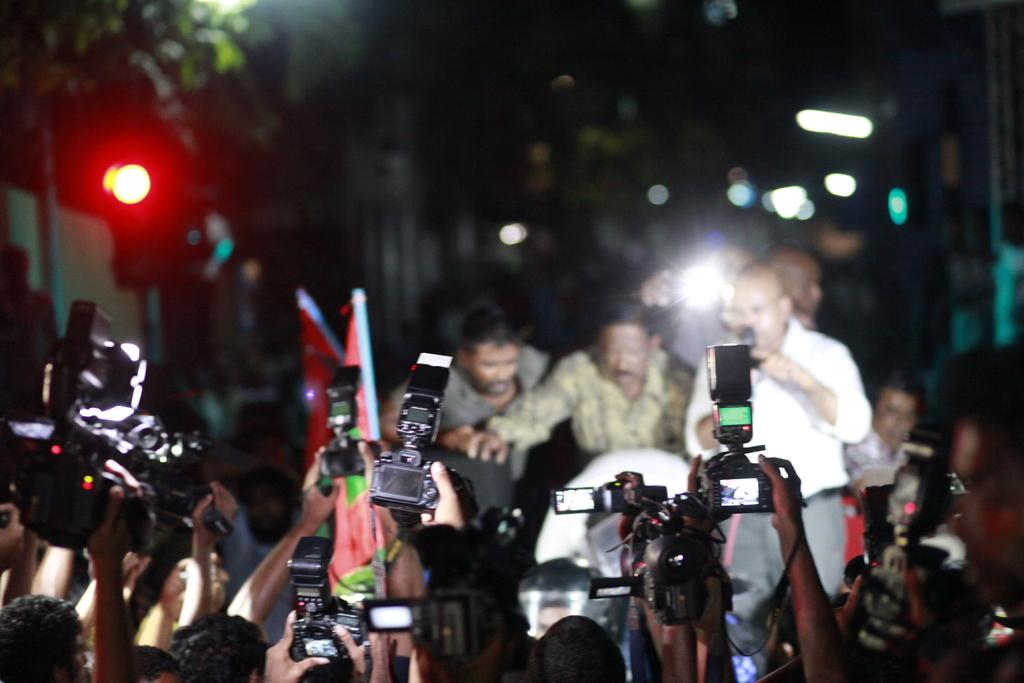What is the main activity being performed by the people in the image? The camera men are taking a photograph in the image. Who are the subjects of the photograph being taken? There are three men standing and posing in the image. How can you describe the background of the image? The background of the image is blurred. What type of rail can be seen in the image? There is no rail present in the image. What condition is the cap in during the photograph? There is no cap visible in the image. 